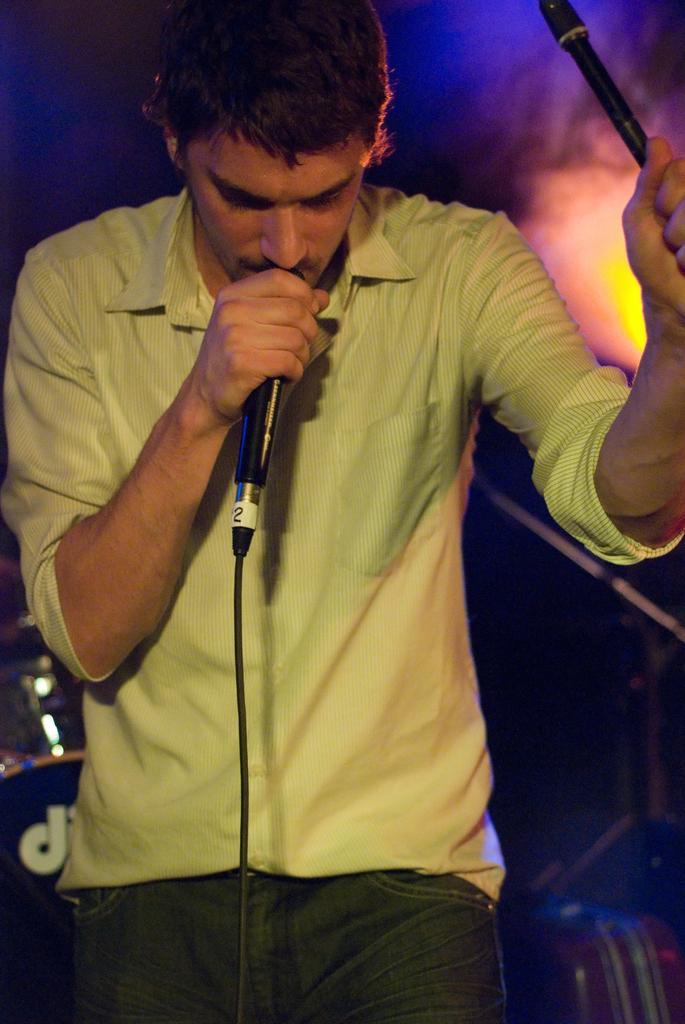In one or two sentences, can you explain what this image depicts? In this image we can see a man standing and holding a mic. In the background there is a band. On the right we can see a light. 